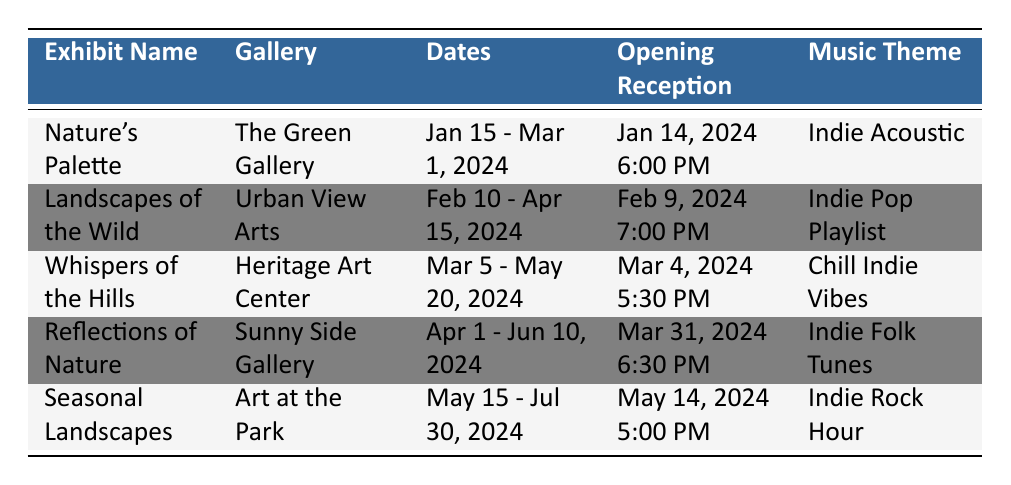What is the opening reception date for "Whispers of the Hills"? The table lists the opening reception for "Whispers of the Hills" as March 4, 2024, at 5:30 PM under the corresponding exhibit name.
Answer: March 4, 2024 5:30 PM Which gallery features the exhibit "Landscapes of the Wild"? The gallery column for the exhibit "Landscapes of the Wild" indicates that it is displayed at Urban View Arts.
Answer: Urban View Arts What is the music theme for "Reflections of Nature"? The music theme is listed directly next to the exhibit name "Reflections of Nature", which states that it features Indie Folk Tunes.
Answer: Indie Folk Tunes How many exhibits have an opening reception that occurs in the evening (after 5:00 PM)? By reviewing the opening reception times, three exhibits have receptions after 5:00 PM: "Landscapes of the Wild" at 7:00 PM, "Reflections of Nature" at 6:30 PM, and "Nature's Palette" at 6:00 PM. Therefore, 3 exhibits have evening receptions.
Answer: 3 True or False: "Seasonal Landscapes" is the last exhibit scheduled in the table. The end date for "Seasonal Landscapes" is July 30, 2024, and it's the last exhibit listed in the table. Therefore, the statement is true.
Answer: True What is the difference in days between the start date of "Nature's Palette" and "Reflections of Nature"? "Nature's Palette" starts on January 15, 2024, and "Reflections of Nature" starts on April 1, 2024. The difference is 76 days (from January 15 to April 1).
Answer: 76 days Which artist is featured in the exhibit that runs the longest? The exhibit with the longest duration is "Whispers of the Hills", which runs from March 5 to May 20, 2024. The artist featured is Sarah Thompson, as indicated in the artist featured column.
Answer: Sarah Thompson What is the total duration of all exhibits combined? The durations of the exhibits are: "Nature's Palette" (46 days), "Landscapes of the Wild" (65 days), "Whispers of the Hills" (76 days), "Reflections of Nature" (70 days), and "Seasonal Landscapes" (76 days). Adding these gives a total of 333 days across all exhibits (46 + 65 + 76 + 70 + 76 = 333).
Answer: 333 days 